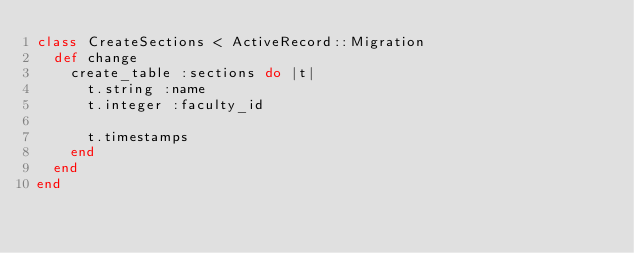<code> <loc_0><loc_0><loc_500><loc_500><_Ruby_>class CreateSections < ActiveRecord::Migration
  def change
    create_table :sections do |t|
      t.string :name
      t.integer :faculty_id

      t.timestamps
    end
  end
end
</code> 